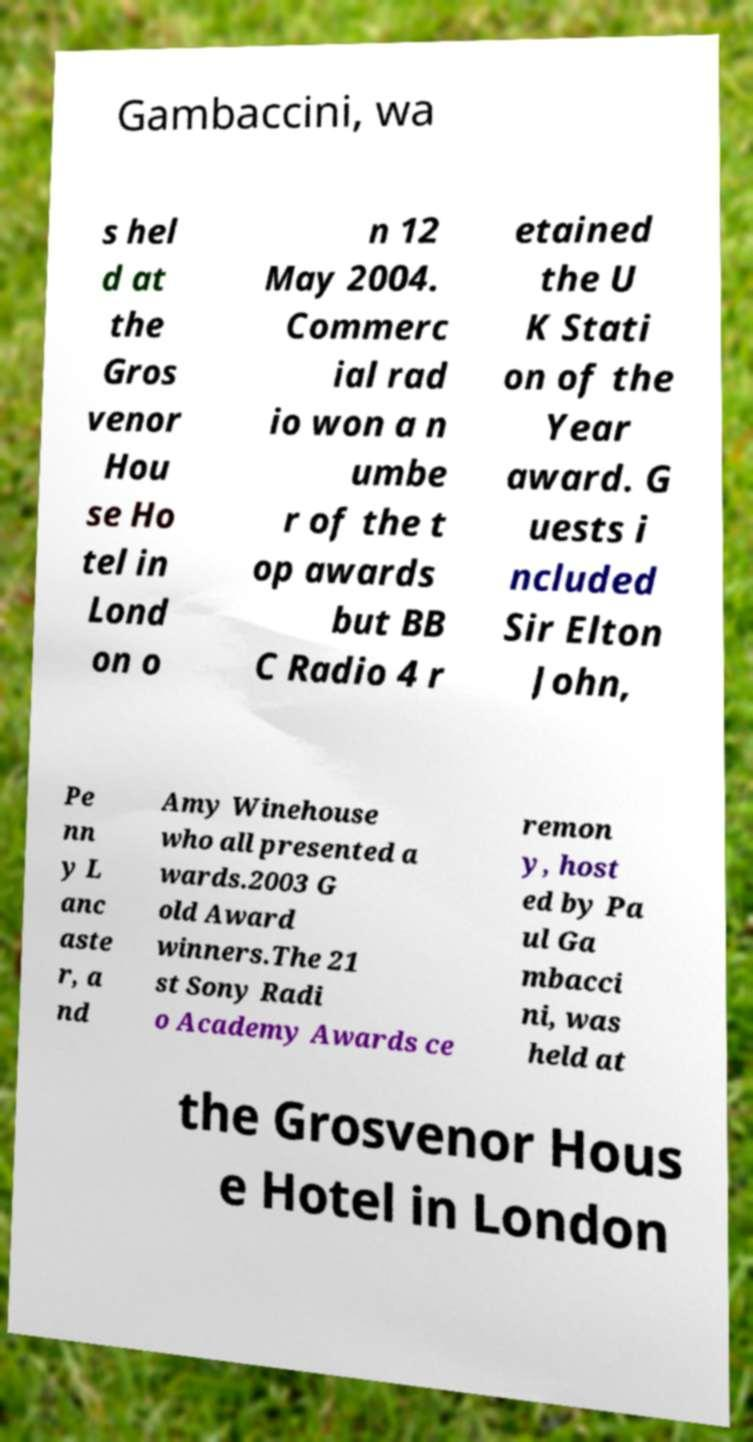Could you assist in decoding the text presented in this image and type it out clearly? Gambaccini, wa s hel d at the Gros venor Hou se Ho tel in Lond on o n 12 May 2004. Commerc ial rad io won a n umbe r of the t op awards but BB C Radio 4 r etained the U K Stati on of the Year award. G uests i ncluded Sir Elton John, Pe nn y L anc aste r, a nd Amy Winehouse who all presented a wards.2003 G old Award winners.The 21 st Sony Radi o Academy Awards ce remon y, host ed by Pa ul Ga mbacci ni, was held at the Grosvenor Hous e Hotel in London 